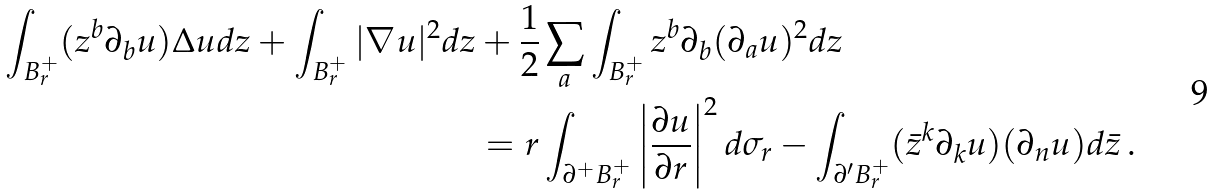<formula> <loc_0><loc_0><loc_500><loc_500>\int _ { B ^ { + } _ { r } } ( z ^ { b } \partial _ { b } u ) \Delta u d z + \int _ { B ^ { + } _ { r } } | \nabla u | ^ { 2 } d z & + \frac { 1 } { 2 } \sum _ { a } \int _ { B ^ { + } _ { r } } z ^ { b } \partial _ { b } ( \partial _ { a } u ) ^ { 2 } d z \\ & = r \int _ { \partial ^ { + } B ^ { + } _ { r } } \left | \frac { \partial u } { \partial r } \right | ^ { 2 } d \sigma _ { r } - \int _ { \partial ^ { \prime } B ^ { + } _ { r } } ( \bar { z } ^ { k } \partial _ { k } u ) ( \partial _ { n } u ) d \bar { z } \, .</formula> 